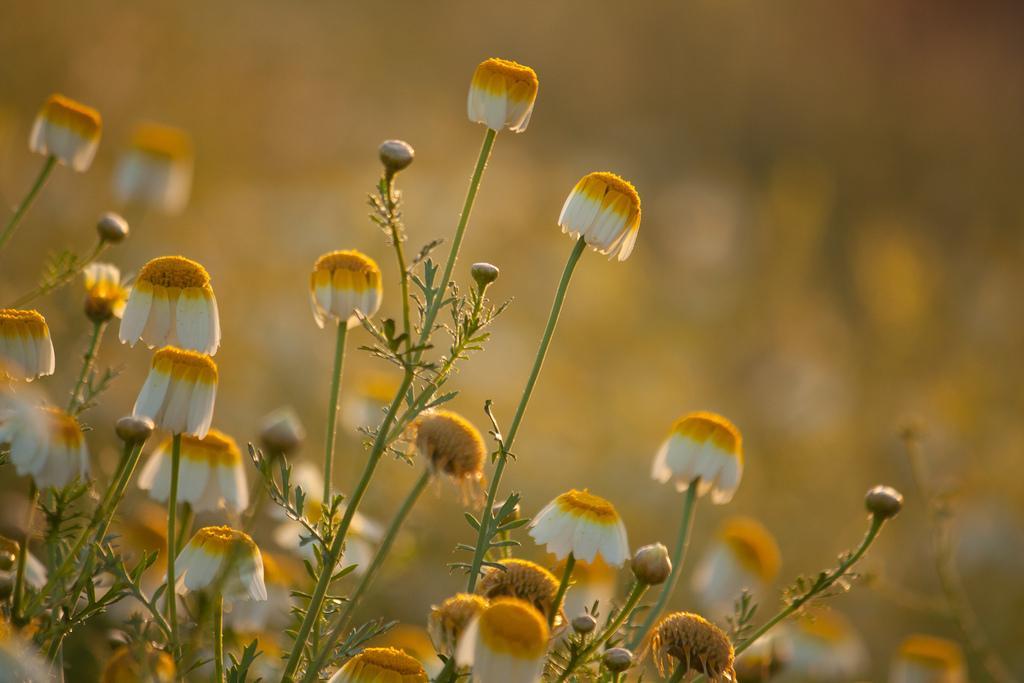Describe this image in one or two sentences. In this image there are plants and flowers and the background of the image is blur. 